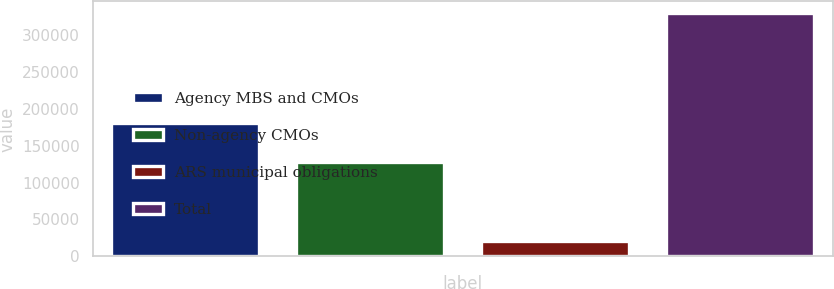Convert chart. <chart><loc_0><loc_0><loc_500><loc_500><bar_chart><fcel>Agency MBS and CMOs<fcel>Non-agency CMOs<fcel>ARS municipal obligations<fcel>Total<nl><fcel>180520<fcel>128045<fcel>20518<fcel>329083<nl></chart> 